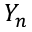Convert formula to latex. <formula><loc_0><loc_0><loc_500><loc_500>Y _ { n }</formula> 